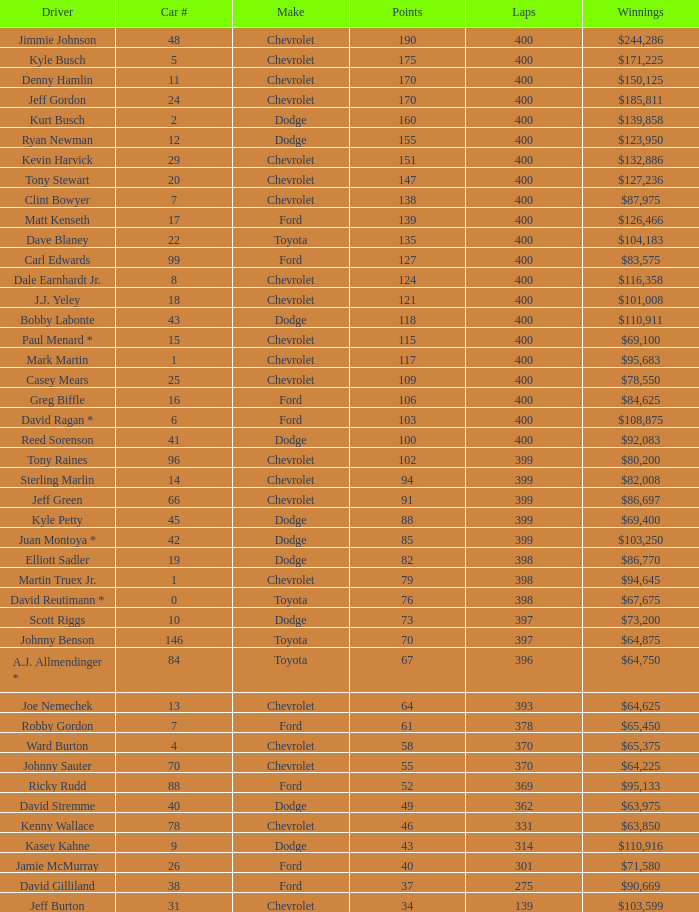What is the make of car 31? Chevrolet. 